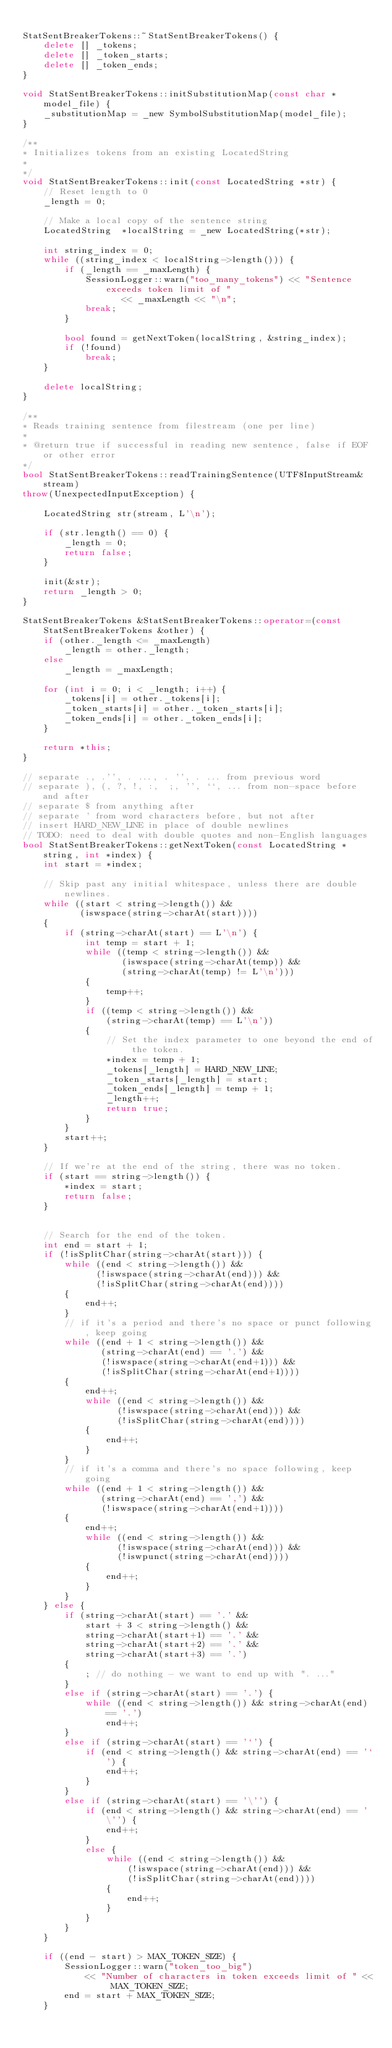<code> <loc_0><loc_0><loc_500><loc_500><_C++_>
StatSentBreakerTokens::~StatSentBreakerTokens() {
	delete [] _tokens;
	delete [] _token_starts;
	delete [] _token_ends;
}

void StatSentBreakerTokens::initSubstitutionMap(const char *model_file) {
	_substitutionMap = _new SymbolSubstitutionMap(model_file);
}

/** 
* Initializes tokens from an existing LocatedString
*
*/
void StatSentBreakerTokens::init(const LocatedString *str) {
	// Reset length to 0
	_length = 0;

	// Make a local copy of the sentence string
	LocatedString  *localString = _new LocatedString(*str);

	int string_index = 0;
	while ((string_index < localString->length())) {
		if (_length == _maxLength) {
			SessionLogger::warn("too_many_tokens") << "Sentence exceeds token limit of "
				   << _maxLength << "\n";
			break;
		}

		bool found = getNextToken(localString, &string_index);
		if (!found) 
			break;
	}

	delete localString;
}

/** 
* Reads training sentence from filestream (one per line)
* 
* @return true if successful in reading new sentence, false if EOF or other error
*/
bool StatSentBreakerTokens::readTrainingSentence(UTF8InputStream& stream) 
throw(UnexpectedInputException) {
	
	LocatedString str(stream, L'\n');
	
	if (str.length() == 0) {
		_length = 0;
		return false;
	}
	
	init(&str);
	return _length > 0;
}

StatSentBreakerTokens &StatSentBreakerTokens::operator=(const StatSentBreakerTokens &other) {
	if (other._length <= _maxLength)
		_length = other._length;
	else
		_length = _maxLength;

	for (int i = 0; i < _length; i++) {
		_tokens[i] = other._tokens[i];
		_token_starts[i] = other._token_starts[i];
		_token_ends[i] = other._token_ends[i];
	}

	return *this;
}

// separate ., .'', . ..., . '', . ... from previous word
// separate ), (, ?, !, :,  ;, '', ``, ... from non-space before and after
// separate $ from anything after
// separate ' from word characters before, but not after
// insert HARD_NEW_LINE in place of double newlines
// TODO: need to deal with double quotes and non-English languages
bool StatSentBreakerTokens::getNextToken(const LocatedString *string, int *index) {
	int start = *index;

	// Skip past any initial whitespace, unless there are double newlines.
	while ((start < string->length()) &&
		   (iswspace(string->charAt(start))))
	{
		if (string->charAt(start) == L'\n') {
			int temp = start + 1;
			while ((temp < string->length()) &&
				   (iswspace(string->charAt(temp)) &&
				   (string->charAt(temp) != L'\n')))
			{
				temp++;
			}
			if ((temp < string->length()) &&
				(string->charAt(temp) == L'\n')) 
			{
				// Set the index parameter to one beyond the end of the token.
				*index = temp + 1;
				_tokens[_length] = HARD_NEW_LINE;
				_token_starts[_length] = start;
				_token_ends[_length] = temp + 1;
				_length++;
				return true;
			}
		}
		start++;
	}

	// If we're at the end of the string, there was no token.
	if (start == string->length()) {
		*index = start;
		return false;
	}

	
	// Search for the end of the token.
	int end = start + 1;
	if (!isSplitChar(string->charAt(start))) {
		while ((end < string->length()) &&
			  (!iswspace(string->charAt(end))) &&
			  (!isSplitChar(string->charAt(end))))
		{
			end++;
		}
		// if it's a period and there's no space or punct following, keep going
		while ((end + 1 < string->length()) && 
			   (string->charAt(end) == '.') &&
			   (!iswspace(string->charAt(end+1))) &&
			   (!isSplitChar(string->charAt(end+1)))) 
		{
			end++;
			while ((end < string->length()) &&
				  (!iswspace(string->charAt(end))) &&
				  (!isSplitChar(string->charAt(end))))
			{
				end++;
			}
		}
		// if it's a comma and there's no space following, keep going
		while ((end + 1 < string->length()) && 
			   (string->charAt(end) == ',') &&
			   (!iswspace(string->charAt(end+1)))) 
		{
			end++;
			while ((end < string->length()) &&
				  (!iswspace(string->charAt(end))) &&
				  (!iswpunct(string->charAt(end))))
			{
				end++;
			}
		}
	} else {
		if (string->charAt(start) == '.' && 
			start + 3 < string->length() &&
			string->charAt(start+1) == '.' &&
			string->charAt(start+2) == '.' &&
			string->charAt(start+3) == '.') 
		{
			; // do nothing - we want to end up with ". ..."
		}
		else if (string->charAt(start) == '.') {
			while ((end < string->length()) && string->charAt(end) == '.')
				end++;
		}
		else if (string->charAt(start) == '`') {
			if (end < string->length() && string->charAt(end) == '`') {
				end++;
			}
		}
		else if (string->charAt(start) == '\'') {
			if (end < string->length() && string->charAt(end) == '\'') {
				end++;
			}
			else {
				while ((end < string->length()) &&
					(!iswspace(string->charAt(end))) &&
					(!isSplitChar(string->charAt(end))))
				{
					end++;
				}
			}
		}
	}

	if ((end - start) > MAX_TOKEN_SIZE) {
		SessionLogger::warn("token_too_big")
			<< "Number of characters in token exceeds limit of " << MAX_TOKEN_SIZE;
		end = start + MAX_TOKEN_SIZE;
	}
</code> 